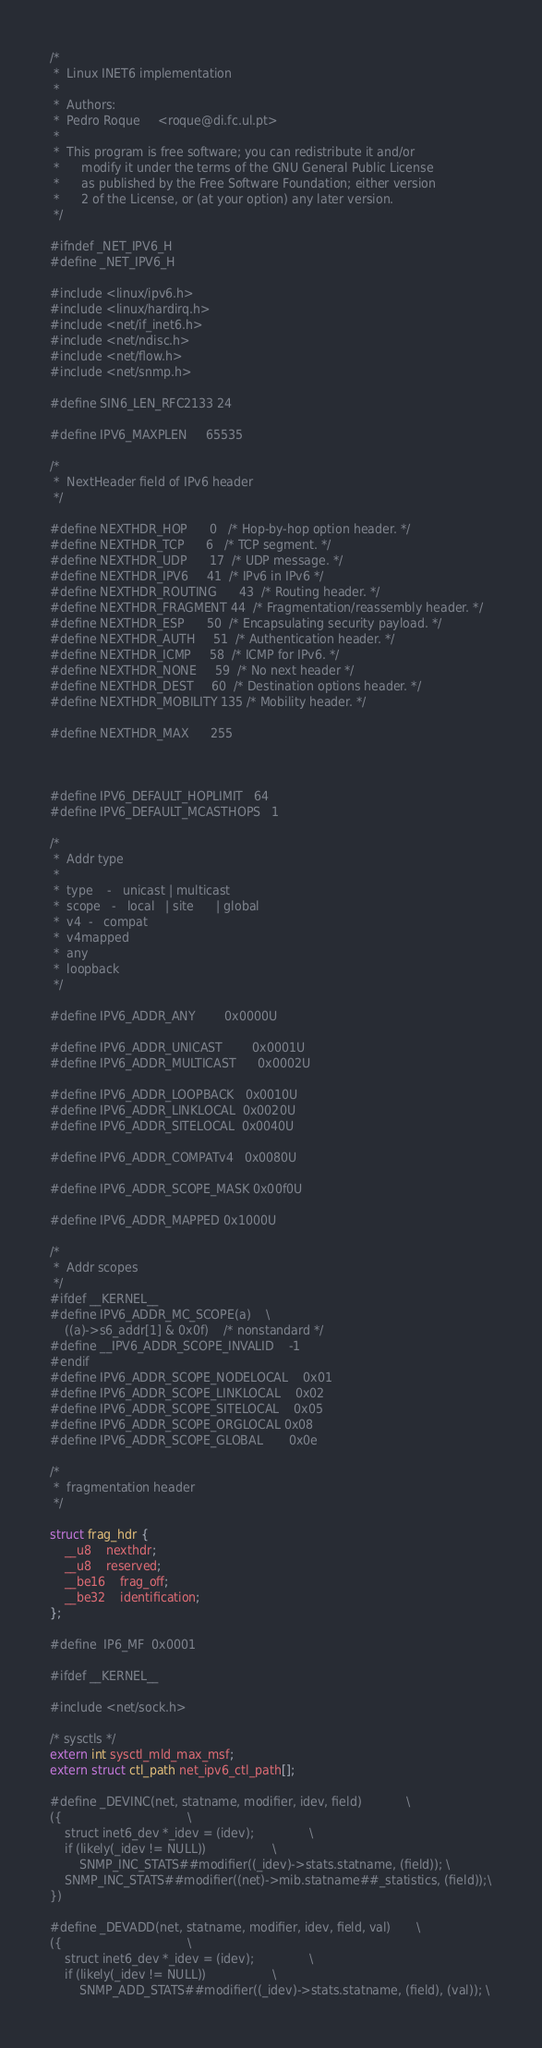<code> <loc_0><loc_0><loc_500><loc_500><_C_>/*
 *	Linux INET6 implementation
 *
 *	Authors:
 *	Pedro Roque		<roque@di.fc.ul.pt>
 *
 *	This program is free software; you can redistribute it and/or
 *      modify it under the terms of the GNU General Public License
 *      as published by the Free Software Foundation; either version
 *      2 of the License, or (at your option) any later version.
 */

#ifndef _NET_IPV6_H
#define _NET_IPV6_H

#include <linux/ipv6.h>
#include <linux/hardirq.h>
#include <net/if_inet6.h>
#include <net/ndisc.h>
#include <net/flow.h>
#include <net/snmp.h>

#define SIN6_LEN_RFC2133	24

#define IPV6_MAXPLEN		65535

/*
 *	NextHeader field of IPv6 header
 */

#define NEXTHDR_HOP		0	/* Hop-by-hop option header. */
#define NEXTHDR_TCP		6	/* TCP segment. */
#define NEXTHDR_UDP		17	/* UDP message. */
#define NEXTHDR_IPV6		41	/* IPv6 in IPv6 */
#define NEXTHDR_ROUTING		43	/* Routing header. */
#define NEXTHDR_FRAGMENT	44	/* Fragmentation/reassembly header. */
#define NEXTHDR_ESP		50	/* Encapsulating security payload. */
#define NEXTHDR_AUTH		51	/* Authentication header. */
#define NEXTHDR_ICMP		58	/* ICMP for IPv6. */
#define NEXTHDR_NONE		59	/* No next header */
#define NEXTHDR_DEST		60	/* Destination options header. */
#define NEXTHDR_MOBILITY	135	/* Mobility header. */

#define NEXTHDR_MAX		255



#define IPV6_DEFAULT_HOPLIMIT   64
#define IPV6_DEFAULT_MCASTHOPS	1

/*
 *	Addr type
 *	
 *	type	-	unicast | multicast
 *	scope	-	local	| site	    | global
 *	v4	-	compat
 *	v4mapped
 *	any
 *	loopback
 */

#define IPV6_ADDR_ANY		0x0000U

#define IPV6_ADDR_UNICAST      	0x0001U	
#define IPV6_ADDR_MULTICAST    	0x0002U	

#define IPV6_ADDR_LOOPBACK	0x0010U
#define IPV6_ADDR_LINKLOCAL	0x0020U
#define IPV6_ADDR_SITELOCAL	0x0040U

#define IPV6_ADDR_COMPATv4	0x0080U

#define IPV6_ADDR_SCOPE_MASK	0x00f0U

#define IPV6_ADDR_MAPPED	0x1000U

/*
 *	Addr scopes
 */
#ifdef __KERNEL__
#define IPV6_ADDR_MC_SCOPE(a)	\
	((a)->s6_addr[1] & 0x0f)	/* nonstandard */
#define __IPV6_ADDR_SCOPE_INVALID	-1
#endif
#define IPV6_ADDR_SCOPE_NODELOCAL	0x01
#define IPV6_ADDR_SCOPE_LINKLOCAL	0x02
#define IPV6_ADDR_SCOPE_SITELOCAL	0x05
#define IPV6_ADDR_SCOPE_ORGLOCAL	0x08
#define IPV6_ADDR_SCOPE_GLOBAL		0x0e

/*
 *	fragmentation header
 */

struct frag_hdr {
	__u8	nexthdr;
	__u8	reserved;
	__be16	frag_off;
	__be32	identification;
};

#define	IP6_MF	0x0001

#ifdef __KERNEL__

#include <net/sock.h>

/* sysctls */
extern int sysctl_mld_max_msf;
extern struct ctl_path net_ipv6_ctl_path[];

#define _DEVINC(net, statname, modifier, idev, field)			\
({									\
	struct inet6_dev *_idev = (idev);				\
	if (likely(_idev != NULL))					\
		SNMP_INC_STATS##modifier((_idev)->stats.statname, (field)); \
	SNMP_INC_STATS##modifier((net)->mib.statname##_statistics, (field));\
})

#define _DEVADD(net, statname, modifier, idev, field, val)		\
({									\
	struct inet6_dev *_idev = (idev);				\
	if (likely(_idev != NULL))					\
		SNMP_ADD_STATS##modifier((_idev)->stats.statname, (field), (val)); \</code> 